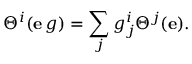Convert formula to latex. <formula><loc_0><loc_0><loc_500><loc_500>\Theta ^ { i } ( e \, g ) = \sum _ { j } g _ { j } ^ { i } \Theta ^ { j } ( e ) .</formula> 